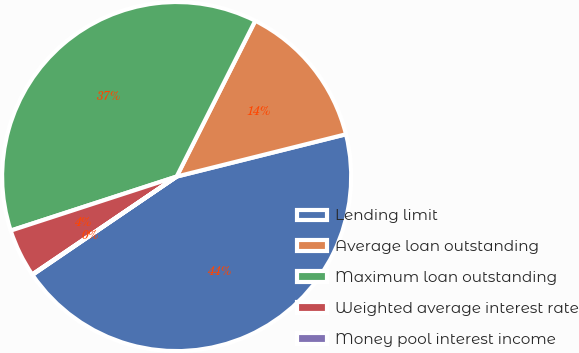Convert chart to OTSL. <chart><loc_0><loc_0><loc_500><loc_500><pie_chart><fcel>Lending limit<fcel>Average loan outstanding<fcel>Maximum loan outstanding<fcel>Weighted average interest rate<fcel>Money pool interest income<nl><fcel>44.38%<fcel>13.67%<fcel>37.45%<fcel>4.47%<fcel>0.04%<nl></chart> 